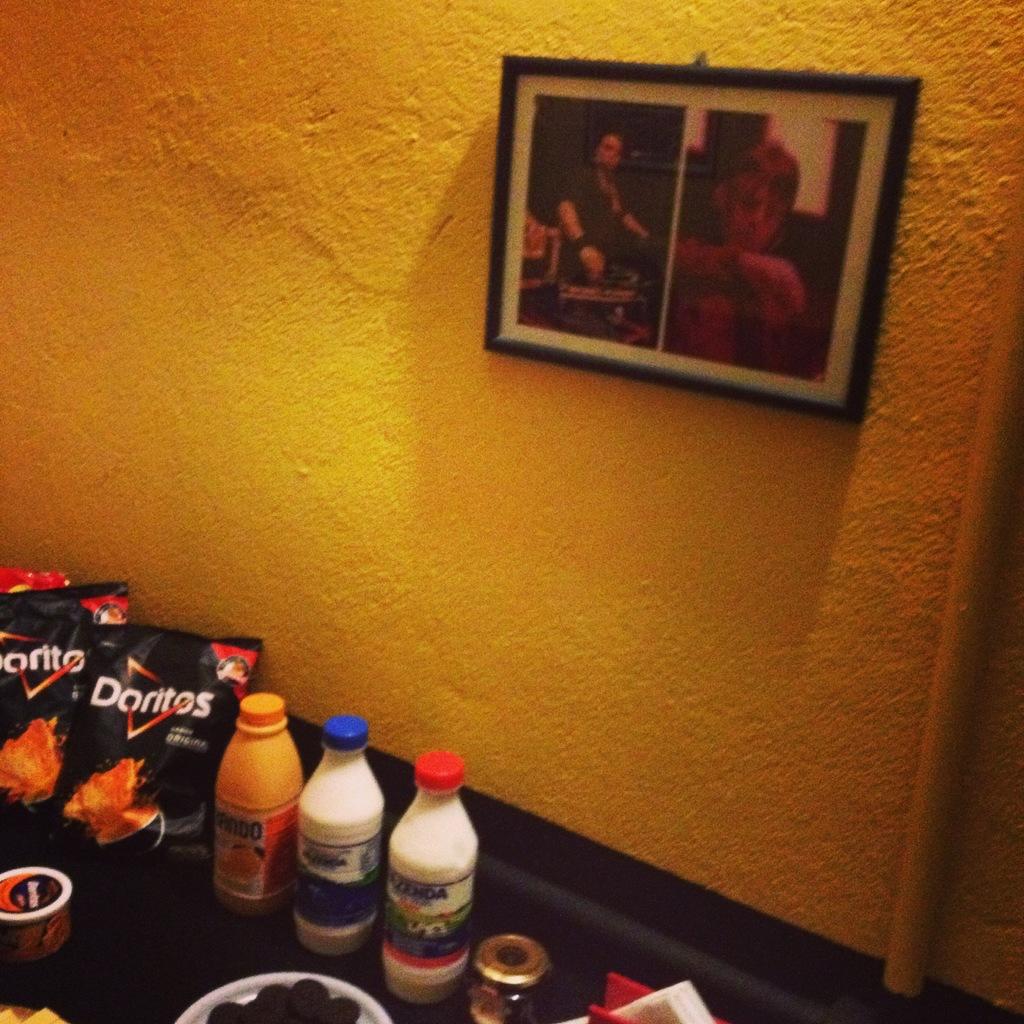The black bags of crisp's are what kind?
Your answer should be compact. Doritos. 